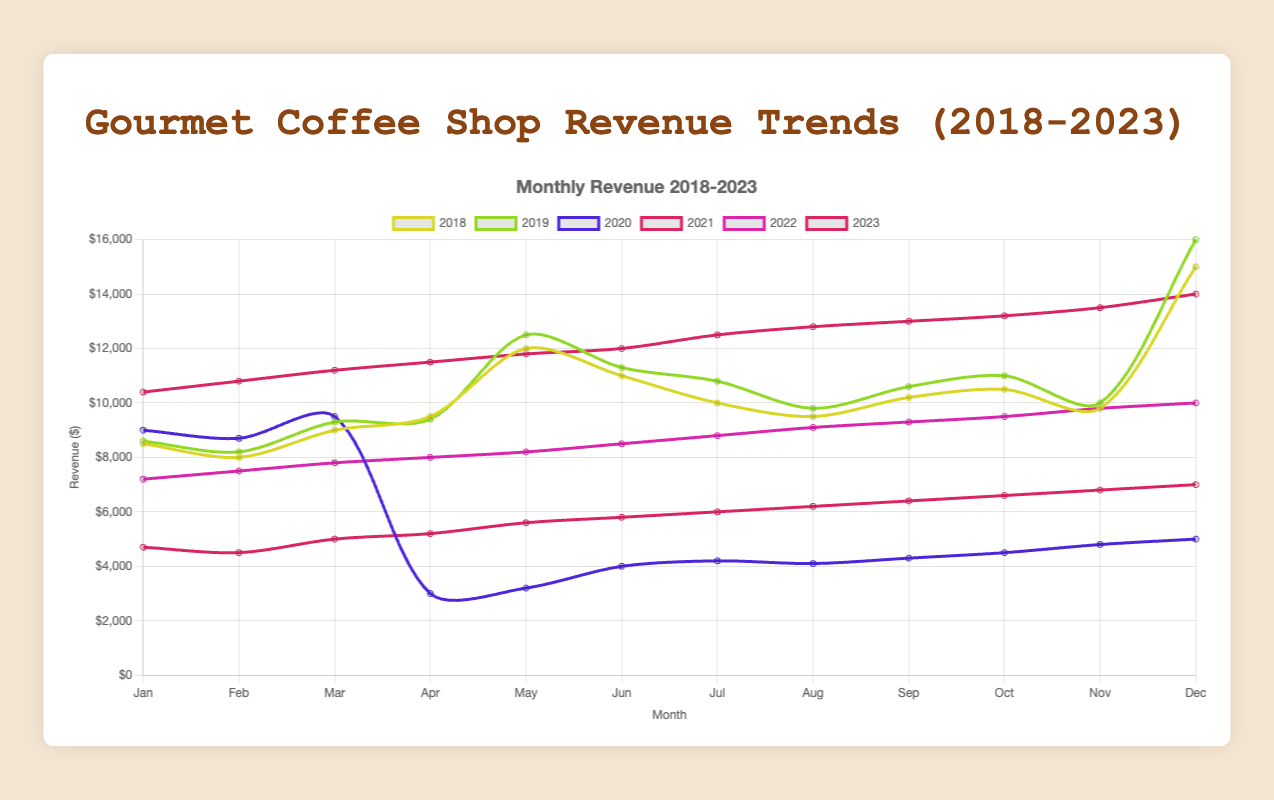Which year had the highest average monthly revenue? To find the highest average monthly revenue, sum the monthly values for each year and then divide by 12. Compare the averages across all years. For 2018: (8500+8000+9000+9500+12000+11000+10000+9500+10200+10500+9800+15000)/12 = 10100. For 2019: (8600+8200+9300+9400+12500+11300+10800+9800+10600+11000+10000+16000)/12 = 10725. For 2020: (9000+8700+9500+3000+3200+4000+4200+4100+4300+4500+4800+5000)/12 = 5450. For 2021: (4700+4500+5000+5200+5600+5800+6000+6200+6400+6600+6800+7000)/12 = 5900. For 2022: (7200+7500+7800+8000+8200+8500+8800+9100+9300+9500+9800+10000)/12 = 8566.67. For 2023: (10400+10800+11200+11500+11800+12000+12500+12800+13000+13200+13500+14000)/12 = 12225. The highest average is for 2023.
Answer: 2023 What is the total revenue for the year 2023? Sum the monthly revenue values for the year 2023. Calculated as: 10400 + 10800 + 11200 + 11500 + 11800 + 12000 + 12500 + 12800 + 13000 + 13200 + 13500 + 14000 = 149700.
Answer: 149700 Which year experienced the largest drop in revenue from March to April? Compute the difference in revenue between March and April for each year, then compare these drops. For 2018: 9000 - 9500 = -500. For 2019: 9300 - 9400 = -100. For 2020: 9500 - 3000 = 6500. For 2021: 5000 - 5200 = -200. For 2022: 7800 - 8000 = -200. For 2023: 11200 - 11500 = -300. The largest drop is seen in 2020 with a difference of 6500.
Answer: 2020 Between which two consecutive years did the average monthly revenue increase the most? Compute the average monthly revenue for each year and find the differences between consecutive years. The averages are: 2018: 10100, 2019: 10725, 2020: 5450, 2021: 5900, 2022: 8566.67, 2023: 12225. Differences: 2019-2018=625, 2020-2019=-5275, 2021-2020=450, 2022-2021=2666.67, 2023-2022=3658.33. The largest increase is between 2022 and 2023.
Answer: 2022 and 2023 What is the general trend in monthly revenues from year to year? Observe the general pattern in revenue changes month by month across the years. 2018 and 2019 generally show steady revenues with notable peaks in December, 2020 shows a significant drop post-March due to external factors, 2021 starts low with gradual recovery, and 2022 onwards there is a steady increase in revenue throughout each month.
Answer: Steady increase with a dip and recovery in 2020-2021 Which month saw the highest revenue in the year 2019? Find the maximum revenue value from the monthly revenue values for the year 2019. The values are: 8600, 8200, 9300, 9400, 12500, 11300, 10800, 9800, 10600, 11000, 10000, 16000. The highest is 16000 in December.
Answer: December How much did the revenue increase from January to December in the year 2021? Subtract January's revenue from December's revenue in 2021. Calculated as: 7000 - 4700 = 2300.
Answer: 2300 What was the impact of the dip in 2020 on the subsequent year's revenue trend? Compare the revenue trajectory in 2021 to 2020. 2020 shows a drastic drop starting April, with very low values maintained through December. 2021 starts lower but shows a gradual and consistent rise each month, indicating a recovery trend.
Answer: Recovery trend in 2021 In which year did the month of May have the highest revenue? Compare the revenue values for May across all years: 2018: 12000, 2019: 12500, 2020: 3200, 2021: 5600, 2022: 8200, 2023: 11800. The highest value is in 2019.
Answer: 2019 Which year had the most stable revenue trend, indicated by the least fluctuation across months? Analyze the month-to-month revenue values and look for the year where the revenue values do not vary significantly. 2021 shows a gradual increase each month, indicating the most stable trend.
Answer: 2021 